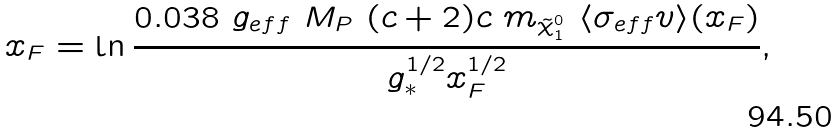<formula> <loc_0><loc_0><loc_500><loc_500>x _ { F } = \ln \frac { 0 . 0 3 8 \ g _ { e f f } \ M _ { P } \ ( c + 2 ) c \ m _ { \tilde { \chi } _ { 1 } ^ { 0 } } \ \langle \sigma _ { e f f } v \rangle ( x _ { F } ) } { g _ { * } ^ { 1 / 2 } x _ { F } ^ { 1 / 2 } } ,</formula> 